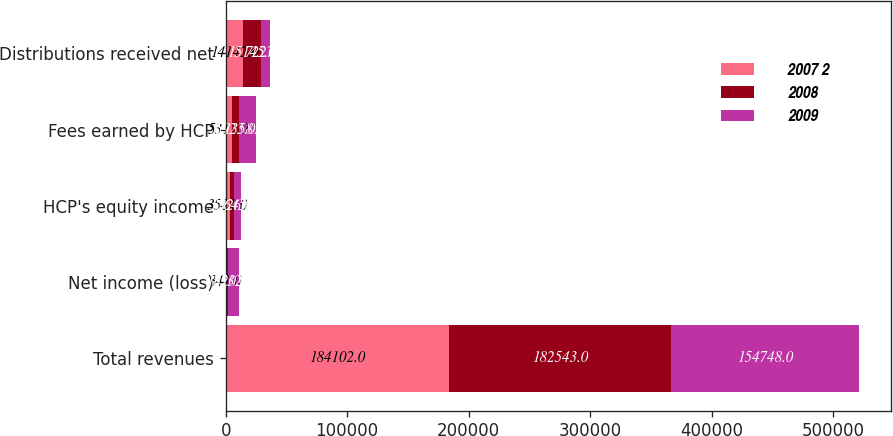Convert chart to OTSL. <chart><loc_0><loc_0><loc_500><loc_500><stacked_bar_chart><ecel><fcel>Total revenues<fcel>Net income (loss)<fcel>HCP's equity income<fcel>Fees earned by HCP<fcel>Distributions received net<nl><fcel>2007 2<fcel>184102<fcel>341<fcel>3511<fcel>5312<fcel>14142<nl><fcel>2008<fcel>182543<fcel>1720<fcel>3326<fcel>5923<fcel>15145<nl><fcel>2009<fcel>154748<fcel>8532<fcel>5645<fcel>13581<fcel>7227.5<nl></chart> 